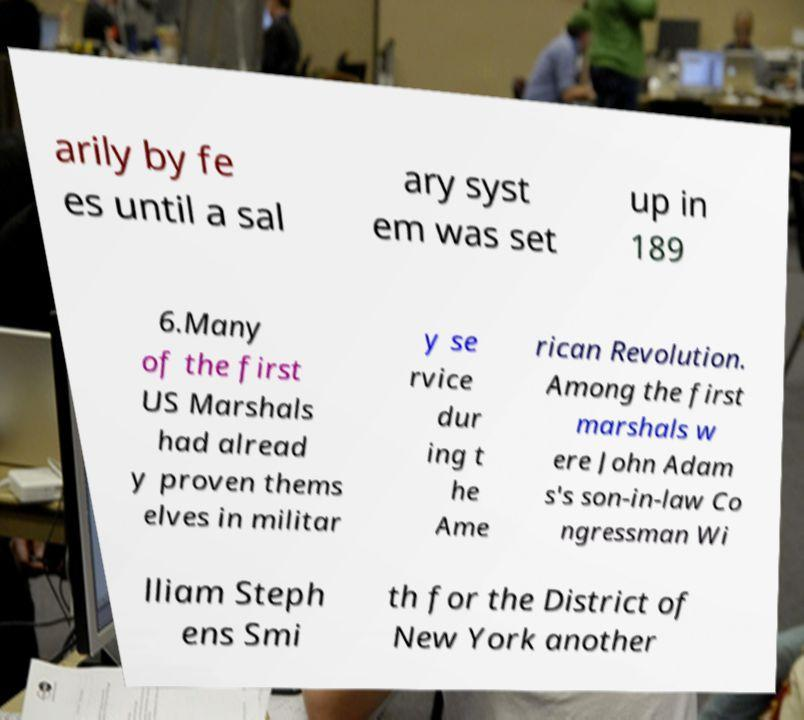Can you accurately transcribe the text from the provided image for me? arily by fe es until a sal ary syst em was set up in 189 6.Many of the first US Marshals had alread y proven thems elves in militar y se rvice dur ing t he Ame rican Revolution. Among the first marshals w ere John Adam s's son-in-law Co ngressman Wi lliam Steph ens Smi th for the District of New York another 